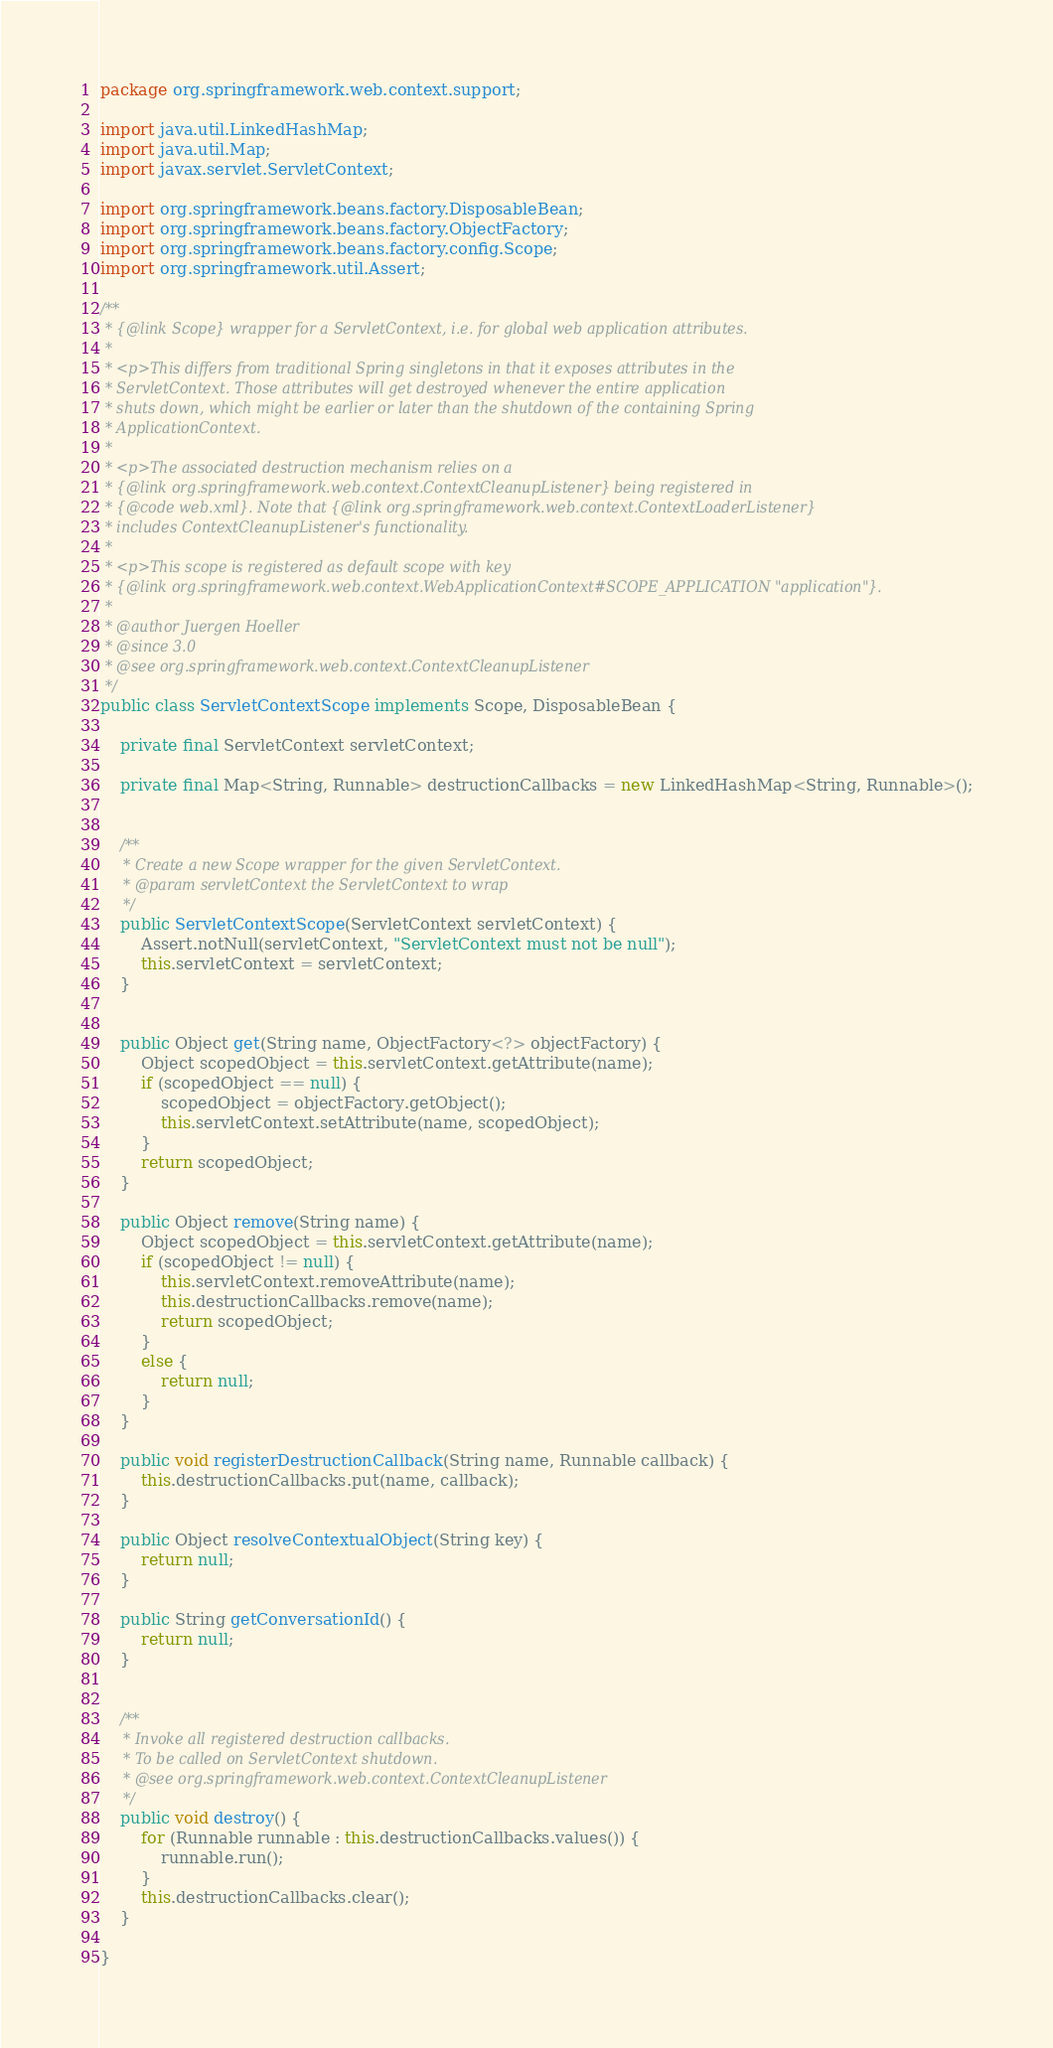<code> <loc_0><loc_0><loc_500><loc_500><_Java_>package org.springframework.web.context.support;

import java.util.LinkedHashMap;
import java.util.Map;
import javax.servlet.ServletContext;

import org.springframework.beans.factory.DisposableBean;
import org.springframework.beans.factory.ObjectFactory;
import org.springframework.beans.factory.config.Scope;
import org.springframework.util.Assert;

/**
 * {@link Scope} wrapper for a ServletContext, i.e. for global web application attributes.
 *
 * <p>This differs from traditional Spring singletons in that it exposes attributes in the
 * ServletContext. Those attributes will get destroyed whenever the entire application
 * shuts down, which might be earlier or later than the shutdown of the containing Spring
 * ApplicationContext.
 *
 * <p>The associated destruction mechanism relies on a
 * {@link org.springframework.web.context.ContextCleanupListener} being registered in
 * {@code web.xml}. Note that {@link org.springframework.web.context.ContextLoaderListener}
 * includes ContextCleanupListener's functionality.
 *
 * <p>This scope is registered as default scope with key
 * {@link org.springframework.web.context.WebApplicationContext#SCOPE_APPLICATION "application"}.
 *
 * @author Juergen Hoeller
 * @since 3.0
 * @see org.springframework.web.context.ContextCleanupListener
 */
public class ServletContextScope implements Scope, DisposableBean {

	private final ServletContext servletContext;

	private final Map<String, Runnable> destructionCallbacks = new LinkedHashMap<String, Runnable>();


	/**
	 * Create a new Scope wrapper for the given ServletContext.
	 * @param servletContext the ServletContext to wrap
	 */
	public ServletContextScope(ServletContext servletContext) {
		Assert.notNull(servletContext, "ServletContext must not be null");
		this.servletContext = servletContext;
	}


	public Object get(String name, ObjectFactory<?> objectFactory) {
		Object scopedObject = this.servletContext.getAttribute(name);
		if (scopedObject == null) {
			scopedObject = objectFactory.getObject();
			this.servletContext.setAttribute(name, scopedObject);
		}
		return scopedObject;
	}

	public Object remove(String name) {
		Object scopedObject = this.servletContext.getAttribute(name);
		if (scopedObject != null) {
			this.servletContext.removeAttribute(name);
			this.destructionCallbacks.remove(name);
			return scopedObject;
		}
		else {
			return null;
		}
	}

	public void registerDestructionCallback(String name, Runnable callback) {
		this.destructionCallbacks.put(name, callback);
	}

	public Object resolveContextualObject(String key) {
		return null;
	}

	public String getConversationId() {
		return null;
	}


	/**
	 * Invoke all registered destruction callbacks.
	 * To be called on ServletContext shutdown.
	 * @see org.springframework.web.context.ContextCleanupListener
	 */
	public void destroy() {
		for (Runnable runnable : this.destructionCallbacks.values()) {
			runnable.run();
		}
		this.destructionCallbacks.clear();
	}

}
</code> 